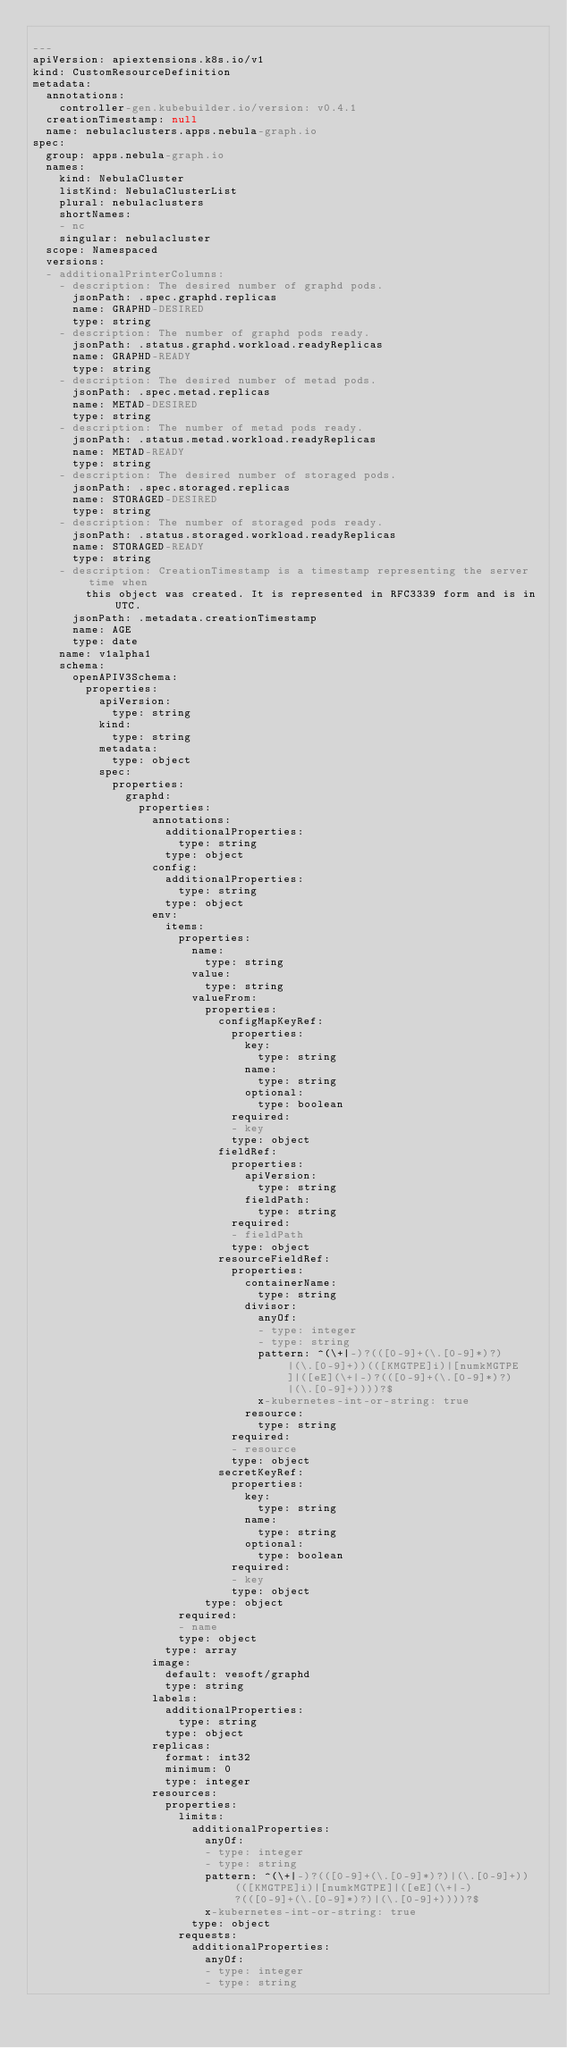<code> <loc_0><loc_0><loc_500><loc_500><_YAML_>
---
apiVersion: apiextensions.k8s.io/v1
kind: CustomResourceDefinition
metadata:
  annotations:
    controller-gen.kubebuilder.io/version: v0.4.1
  creationTimestamp: null
  name: nebulaclusters.apps.nebula-graph.io
spec:
  group: apps.nebula-graph.io
  names:
    kind: NebulaCluster
    listKind: NebulaClusterList
    plural: nebulaclusters
    shortNames:
    - nc
    singular: nebulacluster
  scope: Namespaced
  versions:
  - additionalPrinterColumns:
    - description: The desired number of graphd pods.
      jsonPath: .spec.graphd.replicas
      name: GRAPHD-DESIRED
      type: string
    - description: The number of graphd pods ready.
      jsonPath: .status.graphd.workload.readyReplicas
      name: GRAPHD-READY
      type: string
    - description: The desired number of metad pods.
      jsonPath: .spec.metad.replicas
      name: METAD-DESIRED
      type: string
    - description: The number of metad pods ready.
      jsonPath: .status.metad.workload.readyReplicas
      name: METAD-READY
      type: string
    - description: The desired number of storaged pods.
      jsonPath: .spec.storaged.replicas
      name: STORAGED-DESIRED
      type: string
    - description: The number of storaged pods ready.
      jsonPath: .status.storaged.workload.readyReplicas
      name: STORAGED-READY
      type: string
    - description: CreationTimestamp is a timestamp representing the server time when
        this object was created. It is represented in RFC3339 form and is in UTC.
      jsonPath: .metadata.creationTimestamp
      name: AGE
      type: date
    name: v1alpha1
    schema:
      openAPIV3Schema:
        properties:
          apiVersion:
            type: string
          kind:
            type: string
          metadata:
            type: object
          spec:
            properties:
              graphd:
                properties:
                  annotations:
                    additionalProperties:
                      type: string
                    type: object
                  config:
                    additionalProperties:
                      type: string
                    type: object
                  env:
                    items:
                      properties:
                        name:
                          type: string
                        value:
                          type: string
                        valueFrom:
                          properties:
                            configMapKeyRef:
                              properties:
                                key:
                                  type: string
                                name:
                                  type: string
                                optional:
                                  type: boolean
                              required:
                              - key
                              type: object
                            fieldRef:
                              properties:
                                apiVersion:
                                  type: string
                                fieldPath:
                                  type: string
                              required:
                              - fieldPath
                              type: object
                            resourceFieldRef:
                              properties:
                                containerName:
                                  type: string
                                divisor:
                                  anyOf:
                                  - type: integer
                                  - type: string
                                  pattern: ^(\+|-)?(([0-9]+(\.[0-9]*)?)|(\.[0-9]+))(([KMGTPE]i)|[numkMGTPE]|([eE](\+|-)?(([0-9]+(\.[0-9]*)?)|(\.[0-9]+))))?$
                                  x-kubernetes-int-or-string: true
                                resource:
                                  type: string
                              required:
                              - resource
                              type: object
                            secretKeyRef:
                              properties:
                                key:
                                  type: string
                                name:
                                  type: string
                                optional:
                                  type: boolean
                              required:
                              - key
                              type: object
                          type: object
                      required:
                      - name
                      type: object
                    type: array
                  image:
                    default: vesoft/graphd
                    type: string
                  labels:
                    additionalProperties:
                      type: string
                    type: object
                  replicas:
                    format: int32
                    minimum: 0
                    type: integer
                  resources:
                    properties:
                      limits:
                        additionalProperties:
                          anyOf:
                          - type: integer
                          - type: string
                          pattern: ^(\+|-)?(([0-9]+(\.[0-9]*)?)|(\.[0-9]+))(([KMGTPE]i)|[numkMGTPE]|([eE](\+|-)?(([0-9]+(\.[0-9]*)?)|(\.[0-9]+))))?$
                          x-kubernetes-int-or-string: true
                        type: object
                      requests:
                        additionalProperties:
                          anyOf:
                          - type: integer
                          - type: string</code> 